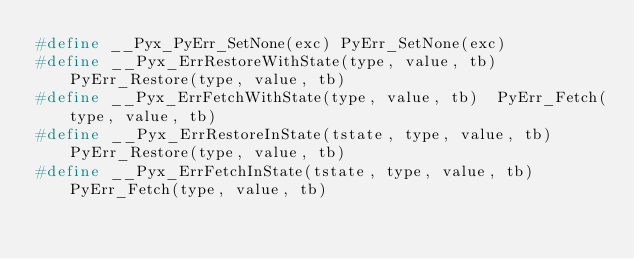<code> <loc_0><loc_0><loc_500><loc_500><_C_>#define __Pyx_PyErr_SetNone(exc) PyErr_SetNone(exc)
#define __Pyx_ErrRestoreWithState(type, value, tb)  PyErr_Restore(type, value, tb)
#define __Pyx_ErrFetchWithState(type, value, tb)  PyErr_Fetch(type, value, tb)
#define __Pyx_ErrRestoreInState(tstate, type, value, tb)  PyErr_Restore(type, value, tb)
#define __Pyx_ErrFetchInState(tstate, type, value, tb)  PyErr_Fetch(type, value, tb)</code> 